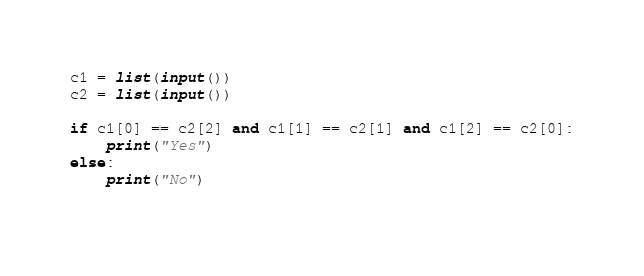<code> <loc_0><loc_0><loc_500><loc_500><_Python_>c1 = list(input())
c2 = list(input())

if c1[0] == c2[2] and c1[1] == c2[1] and c1[2] == c2[0]:
    print("Yes")
else:
    print("No")
    

</code> 